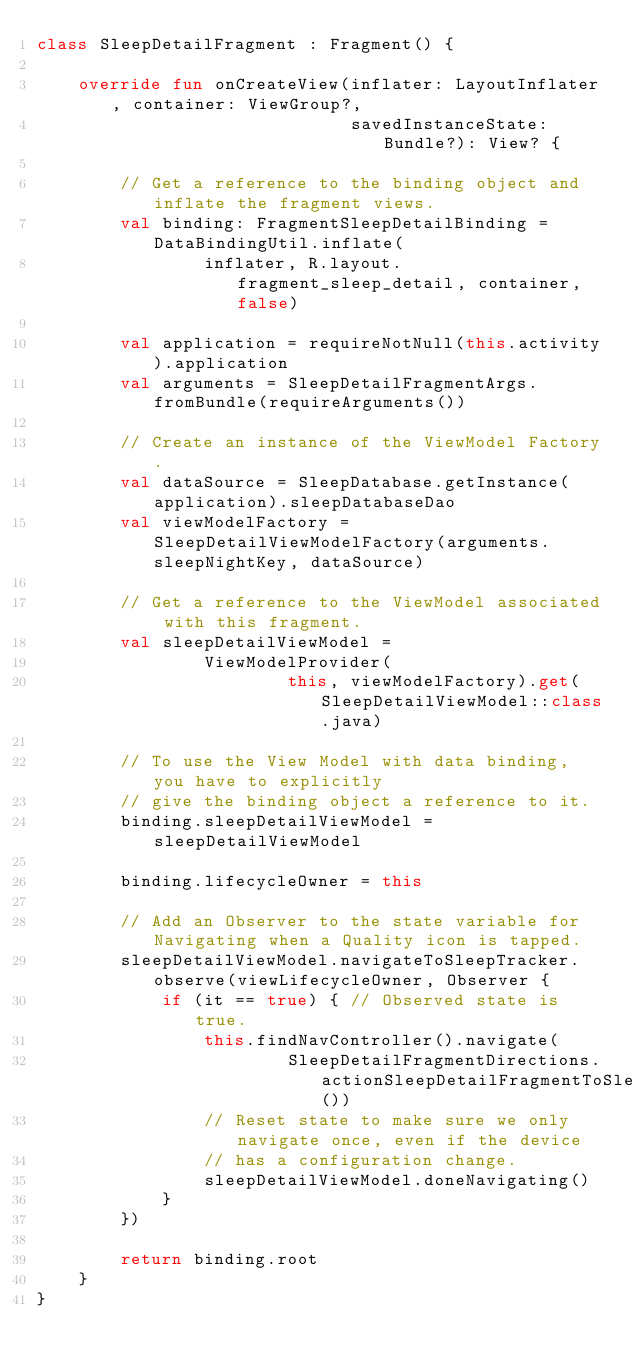Convert code to text. <code><loc_0><loc_0><loc_500><loc_500><_Kotlin_>class SleepDetailFragment : Fragment() {

    override fun onCreateView(inflater: LayoutInflater, container: ViewGroup?,
                              savedInstanceState: Bundle?): View? {

        // Get a reference to the binding object and inflate the fragment views.
        val binding: FragmentSleepDetailBinding = DataBindingUtil.inflate(
                inflater, R.layout.fragment_sleep_detail, container, false)

        val application = requireNotNull(this.activity).application
        val arguments = SleepDetailFragmentArgs.fromBundle(requireArguments())

        // Create an instance of the ViewModel Factory.
        val dataSource = SleepDatabase.getInstance(application).sleepDatabaseDao
        val viewModelFactory = SleepDetailViewModelFactory(arguments.sleepNightKey, dataSource)

        // Get a reference to the ViewModel associated with this fragment.
        val sleepDetailViewModel =
                ViewModelProvider(
                        this, viewModelFactory).get(SleepDetailViewModel::class.java)

        // To use the View Model with data binding, you have to explicitly
        // give the binding object a reference to it.
        binding.sleepDetailViewModel = sleepDetailViewModel

        binding.lifecycleOwner = this

        // Add an Observer to the state variable for Navigating when a Quality icon is tapped.
        sleepDetailViewModel.navigateToSleepTracker.observe(viewLifecycleOwner, Observer {
            if (it == true) { // Observed state is true.
                this.findNavController().navigate(
                        SleepDetailFragmentDirections.actionSleepDetailFragmentToSleepTrackerFragment())
                // Reset state to make sure we only navigate once, even if the device
                // has a configuration change.
                sleepDetailViewModel.doneNavigating()
            }
        })

        return binding.root
    }
}
</code> 